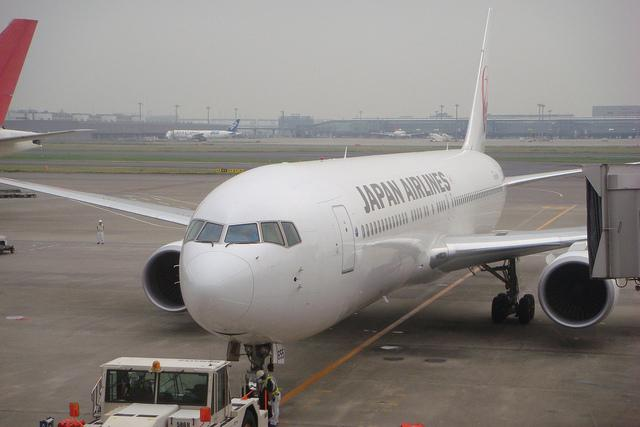What is the official language of this airline's country? Please explain your reasoning. japanese. The plane says the country of japan and they speak japanese. 